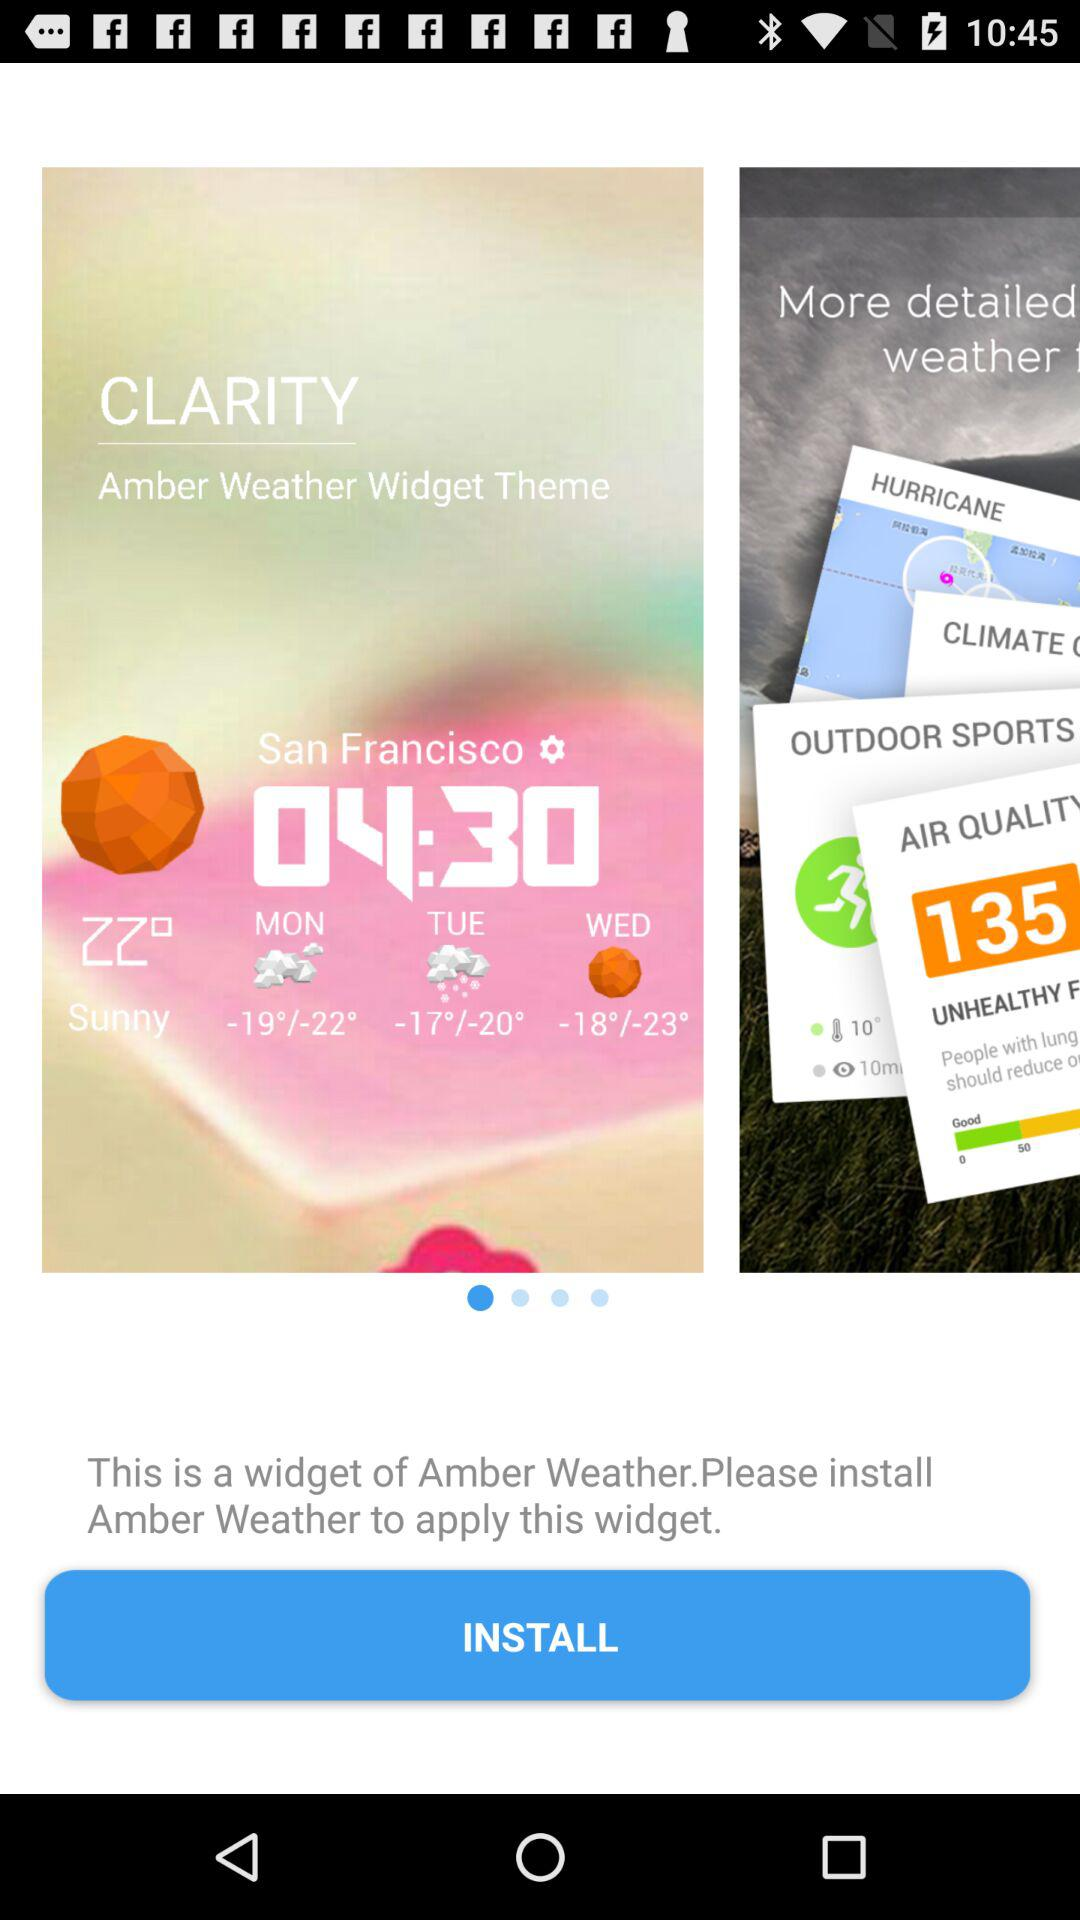How is the weather in San Francisco? The weather in San Francisco is sunny. 